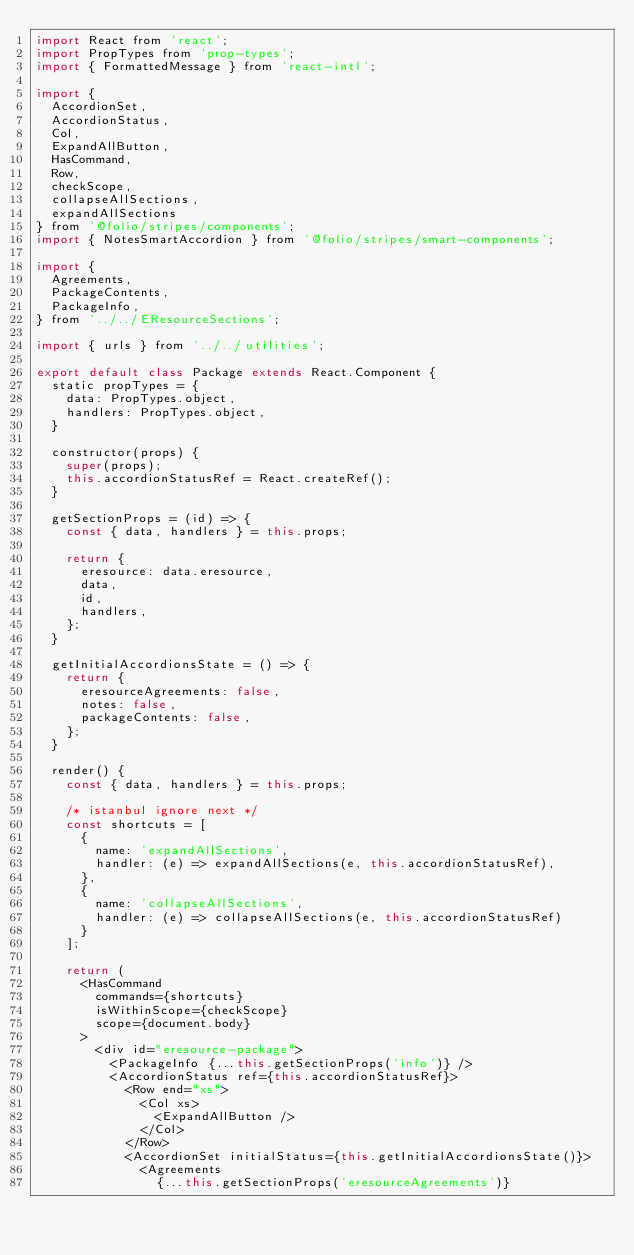Convert code to text. <code><loc_0><loc_0><loc_500><loc_500><_JavaScript_>import React from 'react';
import PropTypes from 'prop-types';
import { FormattedMessage } from 'react-intl';

import {
  AccordionSet,
  AccordionStatus,
  Col,
  ExpandAllButton,
  HasCommand,
  Row,
  checkScope,
  collapseAllSections,
  expandAllSections
} from '@folio/stripes/components';
import { NotesSmartAccordion } from '@folio/stripes/smart-components';

import {
  Agreements,
  PackageContents,
  PackageInfo,
} from '../../EResourceSections';

import { urls } from '../../utilities';

export default class Package extends React.Component {
  static propTypes = {
    data: PropTypes.object,
    handlers: PropTypes.object,
  }

  constructor(props) {
    super(props);
    this.accordionStatusRef = React.createRef();
  }

  getSectionProps = (id) => {
    const { data, handlers } = this.props;

    return {
      eresource: data.eresource,
      data,
      id,
      handlers,
    };
  }

  getInitialAccordionsState = () => {
    return {
      eresourceAgreements: false,
      notes: false,
      packageContents: false,
    };
  }

  render() {
    const { data, handlers } = this.props;

    /* istanbul ignore next */
    const shortcuts = [
      {
        name: 'expandAllSections',
        handler: (e) => expandAllSections(e, this.accordionStatusRef),
      },
      {
        name: 'collapseAllSections',
        handler: (e) => collapseAllSections(e, this.accordionStatusRef)
      }
    ];

    return (
      <HasCommand
        commands={shortcuts}
        isWithinScope={checkScope}
        scope={document.body}
      >
        <div id="eresource-package">
          <PackageInfo {...this.getSectionProps('info')} />
          <AccordionStatus ref={this.accordionStatusRef}>
            <Row end="xs">
              <Col xs>
                <ExpandAllButton />
              </Col>
            </Row>
            <AccordionSet initialStatus={this.getInitialAccordionsState()}>
              <Agreements
                {...this.getSectionProps('eresourceAgreements')}</code> 